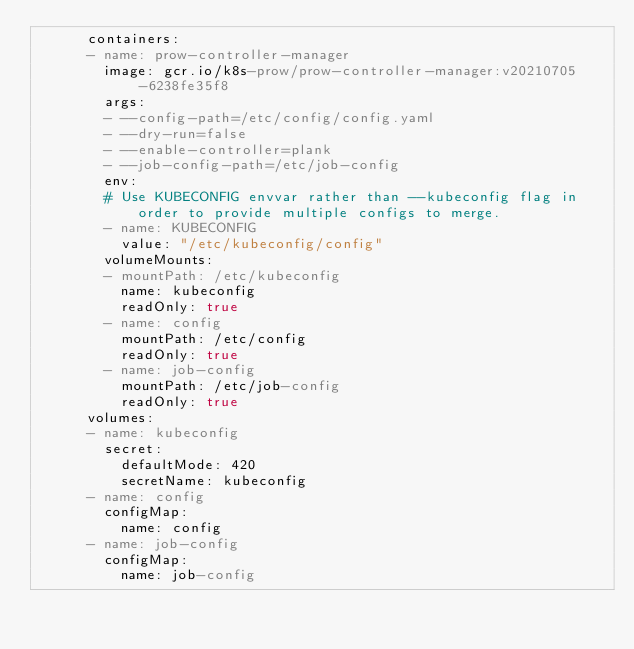Convert code to text. <code><loc_0><loc_0><loc_500><loc_500><_YAML_>      containers:
      - name: prow-controller-manager
        image: gcr.io/k8s-prow/prow-controller-manager:v20210705-6238fe35f8
        args:
        - --config-path=/etc/config/config.yaml
        - --dry-run=false
        - --enable-controller=plank
        - --job-config-path=/etc/job-config
        env:
        # Use KUBECONFIG envvar rather than --kubeconfig flag in order to provide multiple configs to merge.
        - name: KUBECONFIG
          value: "/etc/kubeconfig/config"
        volumeMounts:
        - mountPath: /etc/kubeconfig
          name: kubeconfig
          readOnly: true
        - name: config
          mountPath: /etc/config
          readOnly: true
        - name: job-config
          mountPath: /etc/job-config
          readOnly: true
      volumes:
      - name: kubeconfig
        secret:
          defaultMode: 420
          secretName: kubeconfig
      - name: config
        configMap:
          name: config
      - name: job-config
        configMap:
          name: job-config
</code> 